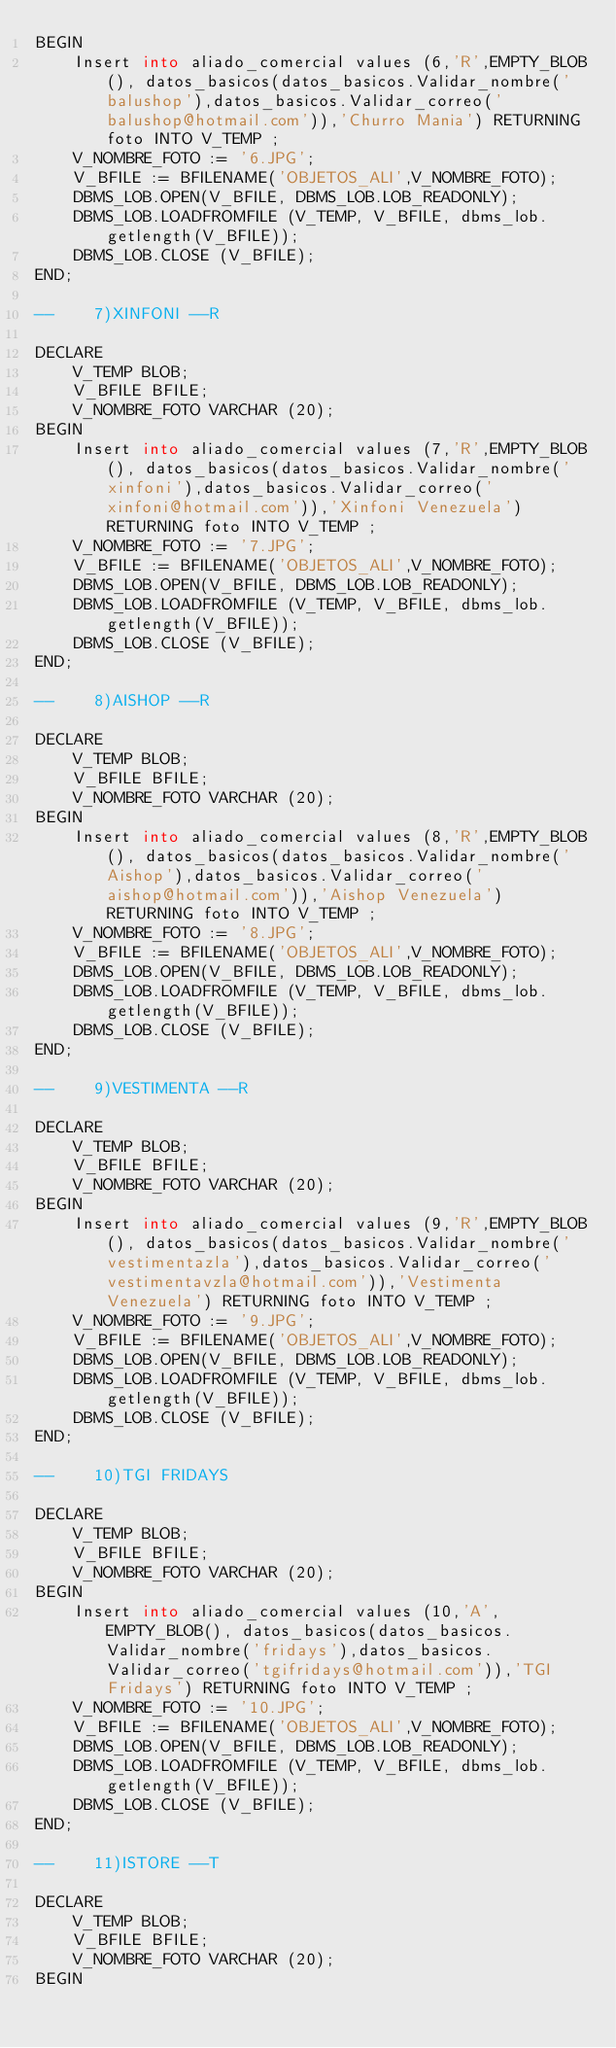<code> <loc_0><loc_0><loc_500><loc_500><_SQL_>BEGIN
    Insert into aliado_comercial values (6,'R',EMPTY_BLOB(), datos_basicos(datos_basicos.Validar_nombre('balushop'),datos_basicos.Validar_correo('balushop@hotmail.com')),'Churro Mania') RETURNING foto INTO V_TEMP ;
    V_NOMBRE_FOTO := '6.JPG';
    V_BFILE := BFILENAME('OBJETOS_ALI',V_NOMBRE_FOTO);
    DBMS_LOB.OPEN(V_BFILE, DBMS_LOB.LOB_READONLY);
    DBMS_LOB.LOADFROMFILE (V_TEMP, V_BFILE, dbms_lob.getlength(V_BFILE));
    DBMS_LOB.CLOSE (V_BFILE);
END;

--    7)XINFONI --R

DECLARE
    V_TEMP BLOB;
    V_BFILE BFILE;
    V_NOMBRE_FOTO VARCHAR (20);
BEGIN
    Insert into aliado_comercial values (7,'R',EMPTY_BLOB(), datos_basicos(datos_basicos.Validar_nombre('xinfoni'),datos_basicos.Validar_correo('xinfoni@hotmail.com')),'Xinfoni Venezuela') RETURNING foto INTO V_TEMP ;
    V_NOMBRE_FOTO := '7.JPG';
    V_BFILE := BFILENAME('OBJETOS_ALI',V_NOMBRE_FOTO);
    DBMS_LOB.OPEN(V_BFILE, DBMS_LOB.LOB_READONLY);
    DBMS_LOB.LOADFROMFILE (V_TEMP, V_BFILE, dbms_lob.getlength(V_BFILE));
    DBMS_LOB.CLOSE (V_BFILE);
END;

--    8)AISHOP --R

DECLARE
    V_TEMP BLOB;
    V_BFILE BFILE;
    V_NOMBRE_FOTO VARCHAR (20);
BEGIN
    Insert into aliado_comercial values (8,'R',EMPTY_BLOB(), datos_basicos(datos_basicos.Validar_nombre('Aishop'),datos_basicos.Validar_correo('aishop@hotmail.com')),'Aishop Venezuela') RETURNING foto INTO V_TEMP ;
    V_NOMBRE_FOTO := '8.JPG';
    V_BFILE := BFILENAME('OBJETOS_ALI',V_NOMBRE_FOTO);
    DBMS_LOB.OPEN(V_BFILE, DBMS_LOB.LOB_READONLY);
    DBMS_LOB.LOADFROMFILE (V_TEMP, V_BFILE, dbms_lob.getlength(V_BFILE));
    DBMS_LOB.CLOSE (V_BFILE);
END;

--    9)VESTIMENTA --R

DECLARE
    V_TEMP BLOB;
    V_BFILE BFILE;
    V_NOMBRE_FOTO VARCHAR (20);
BEGIN
    Insert into aliado_comercial values (9,'R',EMPTY_BLOB(), datos_basicos(datos_basicos.Validar_nombre('vestimentazla'),datos_basicos.Validar_correo('vestimentavzla@hotmail.com')),'Vestimenta Venezuela') RETURNING foto INTO V_TEMP ;
    V_NOMBRE_FOTO := '9.JPG';
    V_BFILE := BFILENAME('OBJETOS_ALI',V_NOMBRE_FOTO);
    DBMS_LOB.OPEN(V_BFILE, DBMS_LOB.LOB_READONLY);
    DBMS_LOB.LOADFROMFILE (V_TEMP, V_BFILE, dbms_lob.getlength(V_BFILE));
    DBMS_LOB.CLOSE (V_BFILE);
END;

--    10)TGI FRIDAYS

DECLARE
    V_TEMP BLOB;
    V_BFILE BFILE;
    V_NOMBRE_FOTO VARCHAR (20);
BEGIN
    Insert into aliado_comercial values (10,'A',EMPTY_BLOB(), datos_basicos(datos_basicos.Validar_nombre('fridays'),datos_basicos.Validar_correo('tgifridays@hotmail.com')),'TGI Fridays') RETURNING foto INTO V_TEMP ;
    V_NOMBRE_FOTO := '10.JPG';
    V_BFILE := BFILENAME('OBJETOS_ALI',V_NOMBRE_FOTO);
    DBMS_LOB.OPEN(V_BFILE, DBMS_LOB.LOB_READONLY);
    DBMS_LOB.LOADFROMFILE (V_TEMP, V_BFILE, dbms_lob.getlength(V_BFILE));
    DBMS_LOB.CLOSE (V_BFILE);
END;

--    11)ISTORE --T

DECLARE
    V_TEMP BLOB;
    V_BFILE BFILE;
    V_NOMBRE_FOTO VARCHAR (20);
BEGIN</code> 